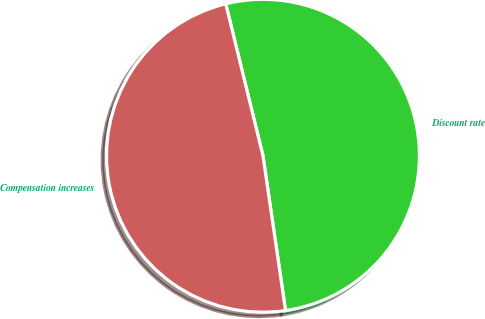Convert chart. <chart><loc_0><loc_0><loc_500><loc_500><pie_chart><fcel>Discount rate<fcel>Compensation increases<nl><fcel>51.52%<fcel>48.48%<nl></chart> 